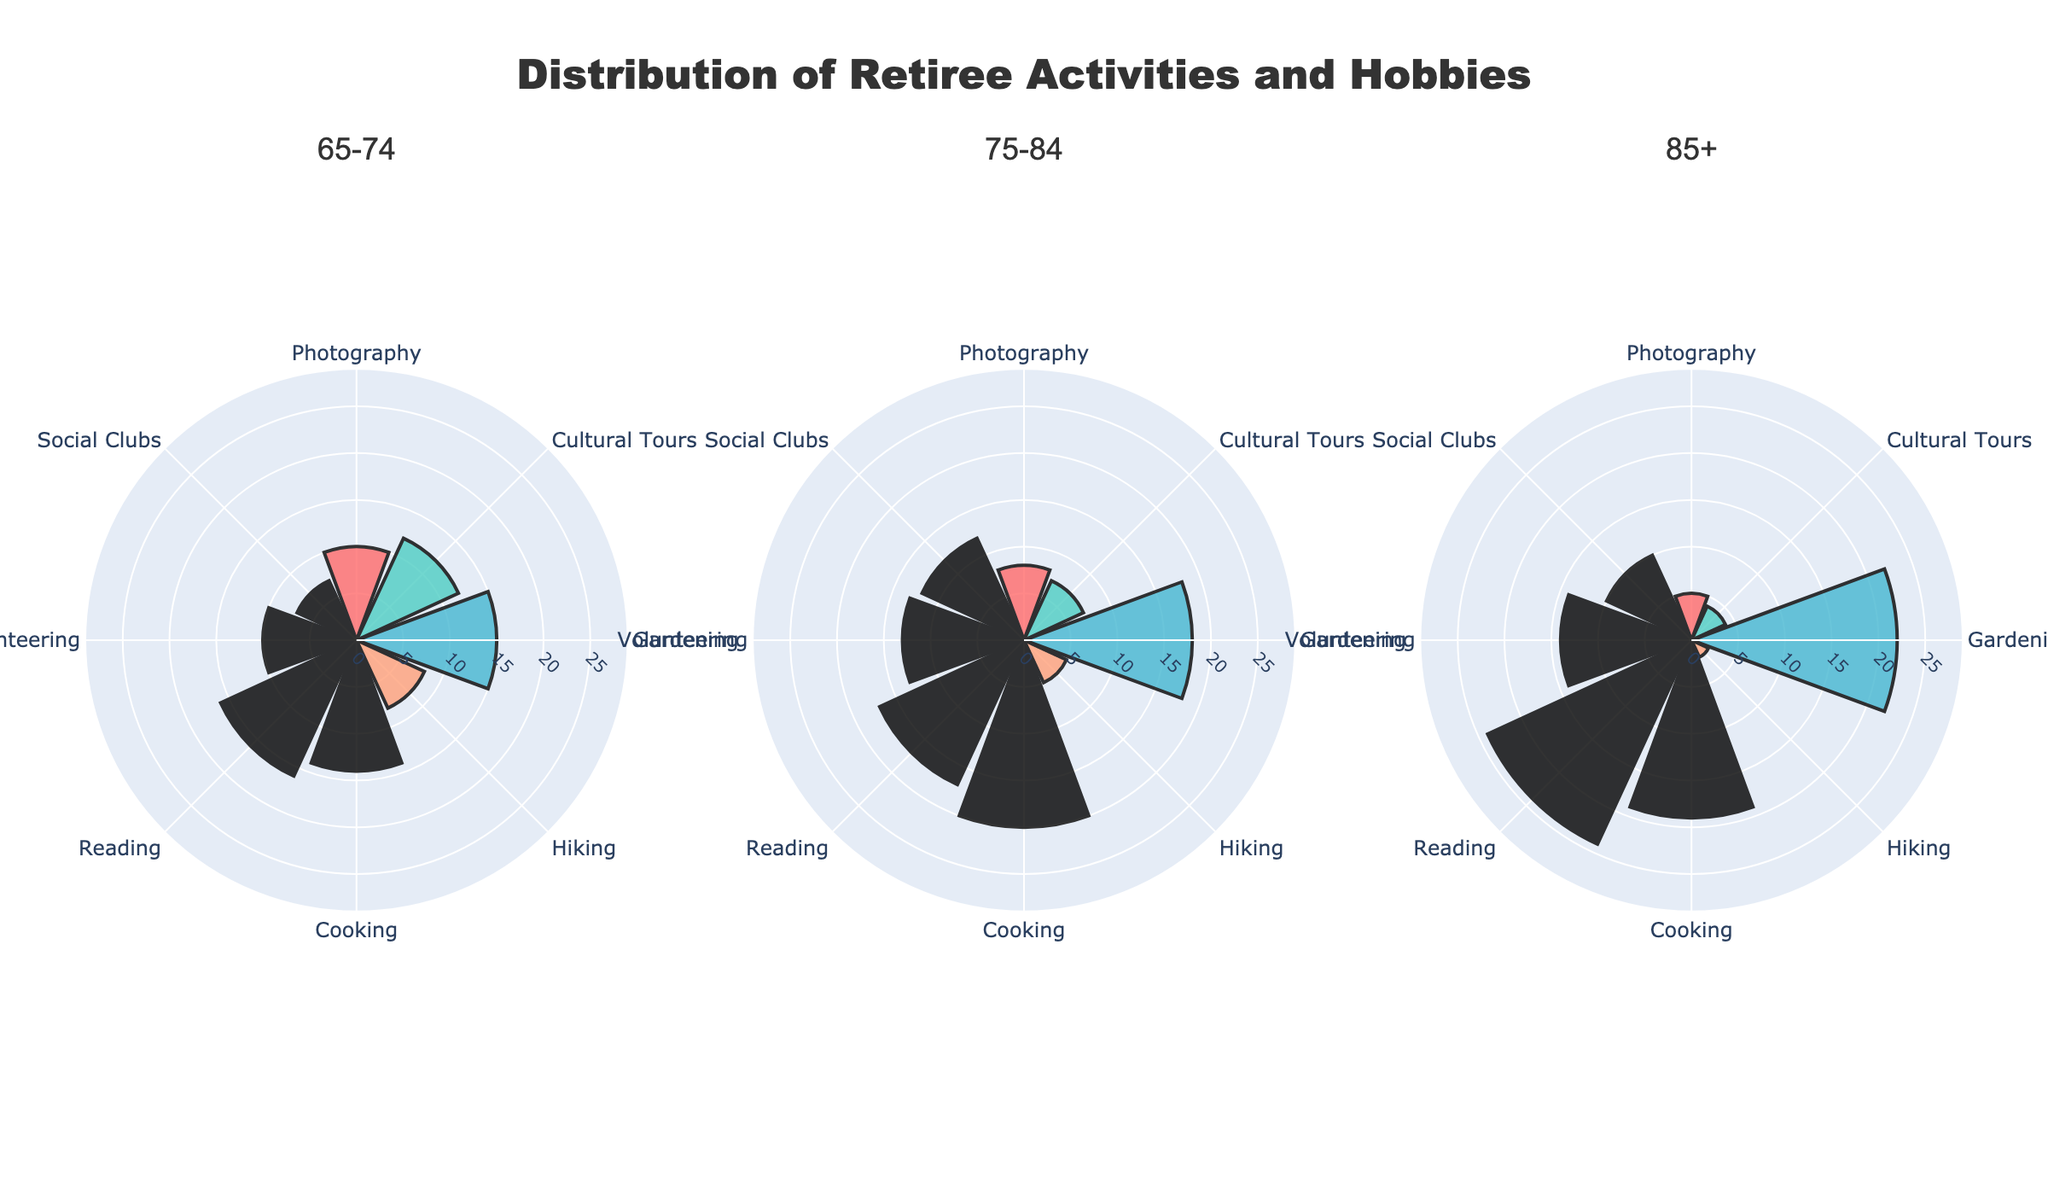what is the activity with the highest percentage in the 65-74 age group? The figure shows the percentage distribution for various activities. For the 65-74 age group, the outer ring's widest segment represents Reading with 16%.
Answer: Reading Which age group shows the highest percentage for gardening? By comparing the segments for Gardening across the three age groups, the widest segment belongs to the 85+ age group with 22%.
Answer: 85+ What is the combined percentage for home-based hobbies (Cooking and Reading) in the 75-84 age group? Both Cooking and Reading percentages are recorded. Cooking stands at 20%, and Reading at 17%, summing up to 37%.
Answer: 37% Which hobby has the sharpest decline in percentage as age increases? The percentages for Photography across the age groups are 10%, 8%, and 5%. The decline from 10% to 5% is 5%, and this steepest decrease among all hobbies.
Answer: Photography How does the percentage for Volunteering change across the age groups? The Volunteering percentages for the age groups are evaluated. They start from 10% in the 65-74 age group, increase to 13% in the 75-84 group, and rise further to 14% among the 85+ group.
Answer: Increases Which travel-related hobby has a higher percentage in every age group, Photography or Cultural Tours? For each age group, both hobbies are compared. Photography is higher in the 65-74 and 75-84 groups (10% vs 12% and 8% vs 7%, respectively), while it's equal in the 85+ group (both at 5%).
Answer: Photography What is the difference in percentage between the highest and lowest Community activities for the 75-84 age group? Social Clubs is at 12%, and Volunteering stands at 13%. The difference is 13% - 12% = 1%.
Answer: 1% Which hobby is most evenly distributed across all age groups? Evaluating each hobby's percentages across all age groups, Reading shows 16%, 17%, and 24%, representing minor variations compared to others.
Answer: Reading What is the lowest percentage activity in the 85+ age group? Hiking has the smallest segment in the 85+ age group, standing at 2%.
Answer: Hiking How do the percentages for Social Clubs change as age progresses? The Social Clubs percentages are checked. The values change from 7% to 12%, then to 10%, indicating a rise followed by a slight fall.
Answer: Increase then decrease 